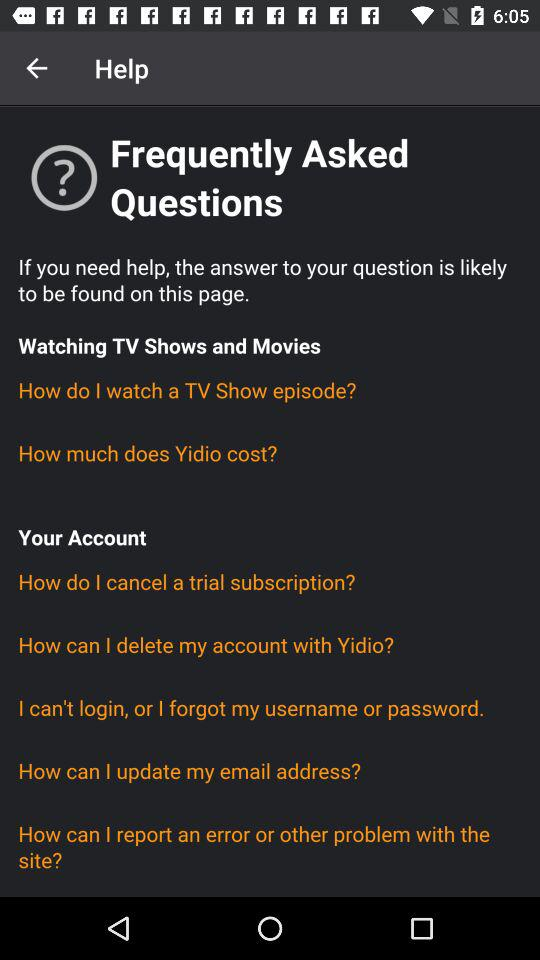How many FAQs are about watching TV shows and movies?
Answer the question using a single word or phrase. 2 